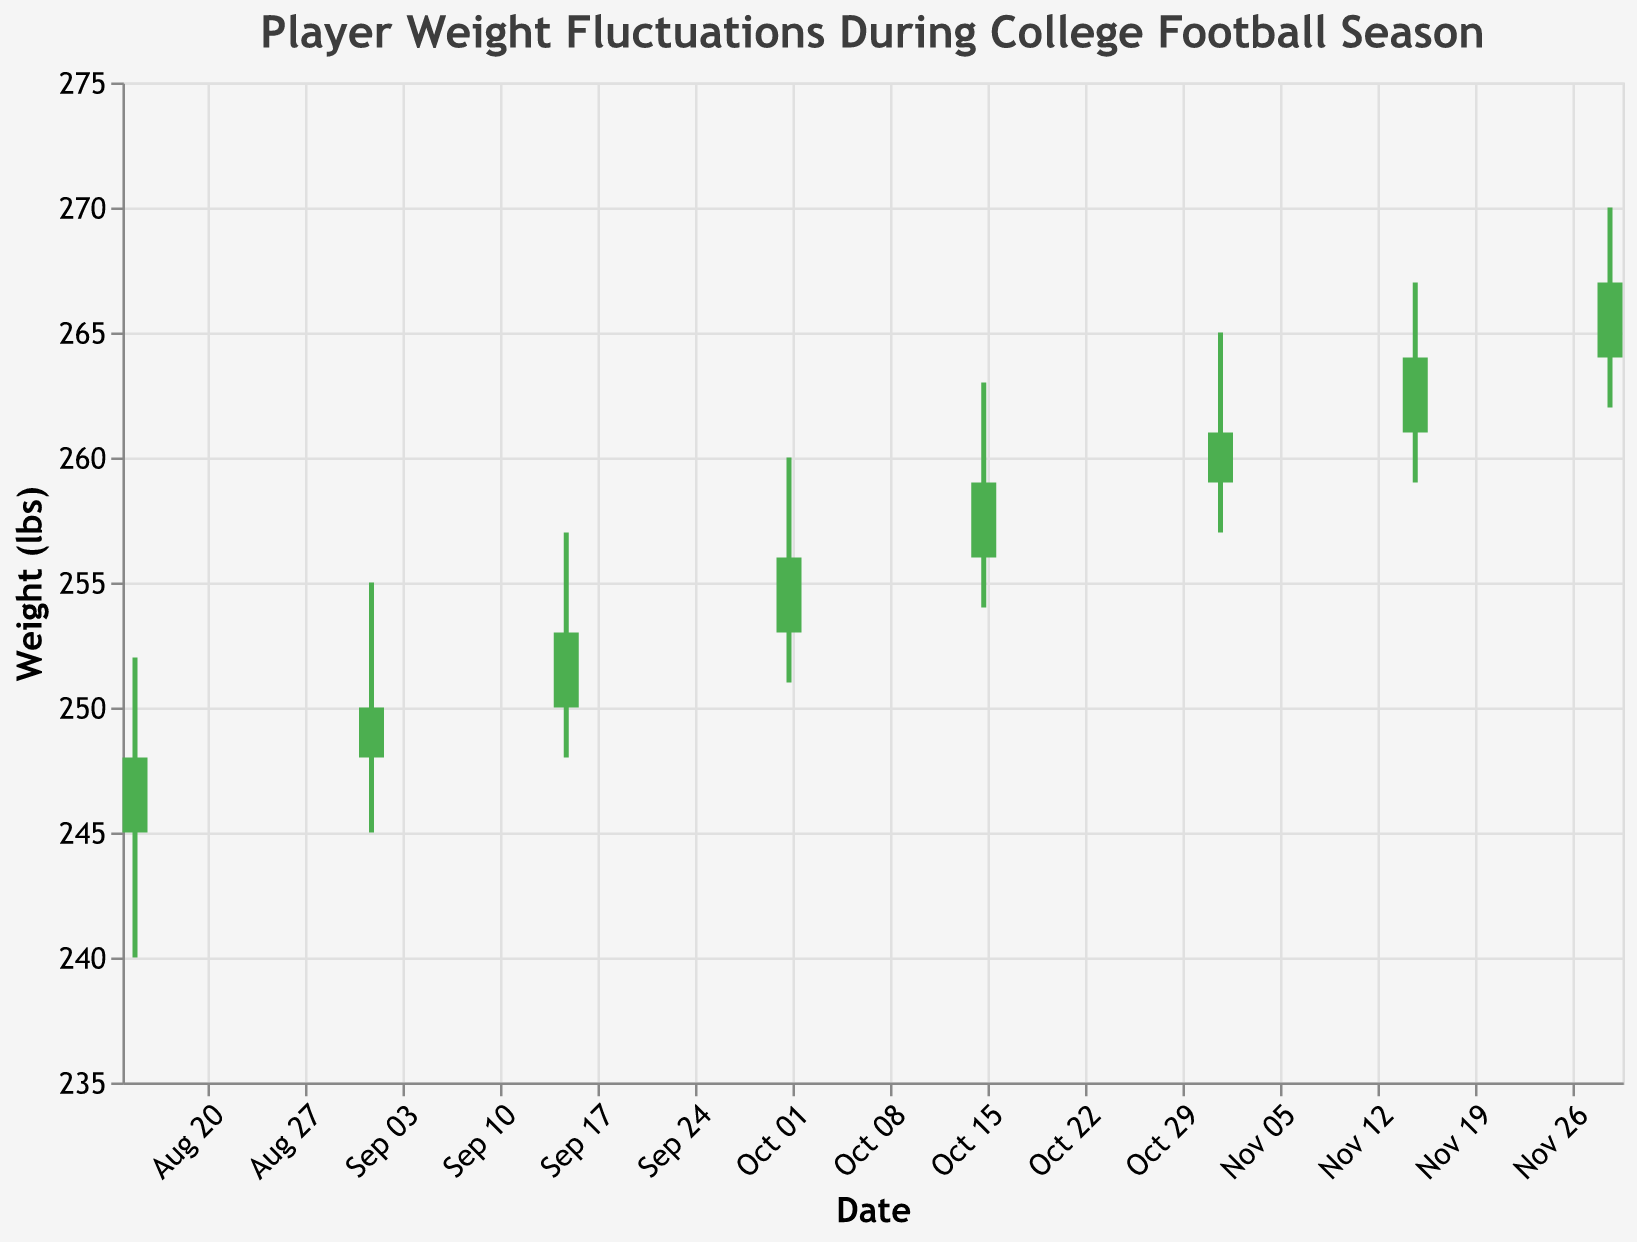What's the title of the figure? The title is usually displayed at the top of the figure. In this case, it's explicitly mentioned in the provided code that the title text is "Player Weight Fluctuations During College Football Season".
Answer: Player Weight Fluctuations During College Football Season How many dates are represented in the chart? Each data point corresponds to a specific date. By counting the number of Date entries in the data array, we find there are 8 dates.
Answer: 8 Which date shows the highest value for the player's weight? To find the highest weight, we need to look at the "High" values for each date. The highest value is 270 recorded on 2023-11-29.
Answer: 2023-11-29 On which date did the player's weight close lower than it opened? We compare the "Open" and "Close" values for each date. The only date where the Close value is less than the Open value is 2023-08-15.
Answer: 2023-08-15 What was the weight range (difference between High and Low) on 2023-10-01? The High for 2023-10-01 is 260 and the Low is 251. The range is calculated as 260 - 251.
Answer: 9 lbs By how much did the player's weight increase from 2023-08-15 to 2023-11-29? The Close value on 2023-08-15 is 248, and on 2023-11-29 it is 267. The increase is calculated as 267 - 248.
Answer: 19 lbs Which two consecutive dates show the largest increase in the player's weight? We look at the Close values for each date and find the difference between consecutive dates. The largest increase is from 2023-11-15 (264) to 2023-11-29 (267), which is 267 - 264.
Answer: 2023-11-15 to 2023-11-29 What is the average High value across all dates? Sum all High values (252 + 255 + 257 + 260 + 263 + 265 + 267 + 270) which equals 2089, then divide by the number of dates (8). 2089 / 8 = 261.125
Answer: 261.125 lbs How many times did the player’s weight Close higher than it Opened? We compare the "Open" and "Close" values. The Close value is higher than the Open value for seven dates (2023-09-01, 2023-09-15, 2023-10-01, 2023-10-15, 2023-11-01, 2023-11-15, 2023-11-29).
Answer: 7 On which date was the player's weight most stable (smallest difference between High and Low values)? We find the difference between High and Low for each date, then identify the smallest difference. For 2023-09-01, the difference is 255 - 245 = 10 lbs, which is the smallest among all dates.
Answer: 2023-09-01 